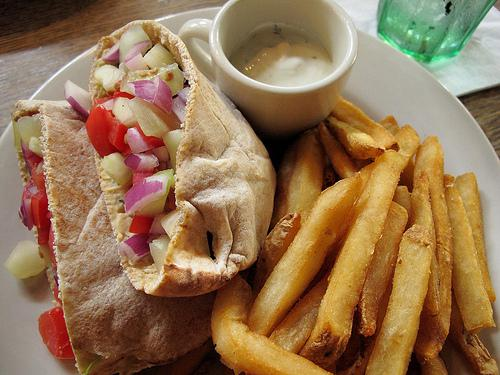Question: what is in the plate?
Choices:
A. Food.
B. Fork.
C. Napkin.
D. Soapy water.
Answer with the letter. Answer: A Question: who is in the photo?
Choices:
A. Pluto Nash.
B. William Shatner.
C. Leonard Nimoy.
D. Nobody.
Answer with the letter. Answer: D 